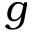<formula> <loc_0><loc_0><loc_500><loc_500>g</formula> 